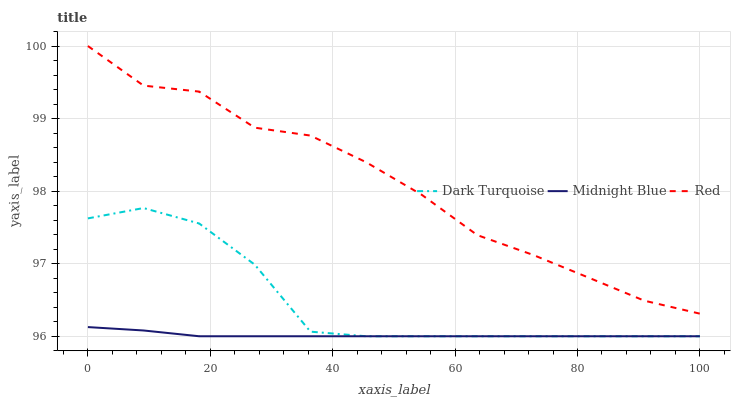Does Midnight Blue have the minimum area under the curve?
Answer yes or no. Yes. Does Red have the maximum area under the curve?
Answer yes or no. Yes. Does Red have the minimum area under the curve?
Answer yes or no. No. Does Midnight Blue have the maximum area under the curve?
Answer yes or no. No. Is Midnight Blue the smoothest?
Answer yes or no. Yes. Is Red the roughest?
Answer yes or no. Yes. Is Red the smoothest?
Answer yes or no. No. Is Midnight Blue the roughest?
Answer yes or no. No. Does Dark Turquoise have the lowest value?
Answer yes or no. Yes. Does Red have the lowest value?
Answer yes or no. No. Does Red have the highest value?
Answer yes or no. Yes. Does Midnight Blue have the highest value?
Answer yes or no. No. Is Midnight Blue less than Red?
Answer yes or no. Yes. Is Red greater than Dark Turquoise?
Answer yes or no. Yes. Does Dark Turquoise intersect Midnight Blue?
Answer yes or no. Yes. Is Dark Turquoise less than Midnight Blue?
Answer yes or no. No. Is Dark Turquoise greater than Midnight Blue?
Answer yes or no. No. Does Midnight Blue intersect Red?
Answer yes or no. No. 